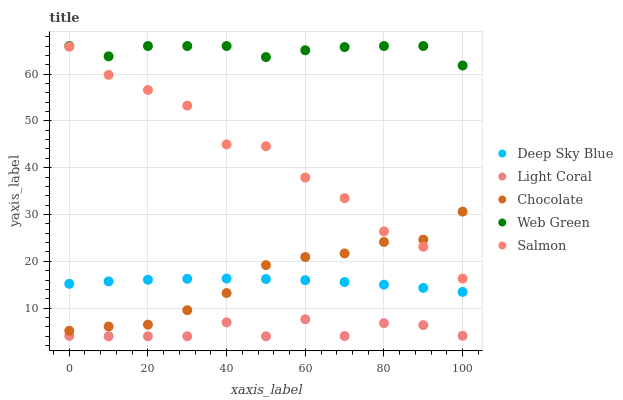Does Light Coral have the minimum area under the curve?
Answer yes or no. Yes. Does Web Green have the maximum area under the curve?
Answer yes or no. Yes. Does Salmon have the minimum area under the curve?
Answer yes or no. No. Does Salmon have the maximum area under the curve?
Answer yes or no. No. Is Deep Sky Blue the smoothest?
Answer yes or no. Yes. Is Salmon the roughest?
Answer yes or no. Yes. Is Web Green the smoothest?
Answer yes or no. No. Is Web Green the roughest?
Answer yes or no. No. Does Light Coral have the lowest value?
Answer yes or no. Yes. Does Salmon have the lowest value?
Answer yes or no. No. Does Web Green have the highest value?
Answer yes or no. Yes. Does Salmon have the highest value?
Answer yes or no. No. Is Light Coral less than Chocolate?
Answer yes or no. Yes. Is Web Green greater than Salmon?
Answer yes or no. Yes. Does Deep Sky Blue intersect Chocolate?
Answer yes or no. Yes. Is Deep Sky Blue less than Chocolate?
Answer yes or no. No. Is Deep Sky Blue greater than Chocolate?
Answer yes or no. No. Does Light Coral intersect Chocolate?
Answer yes or no. No. 